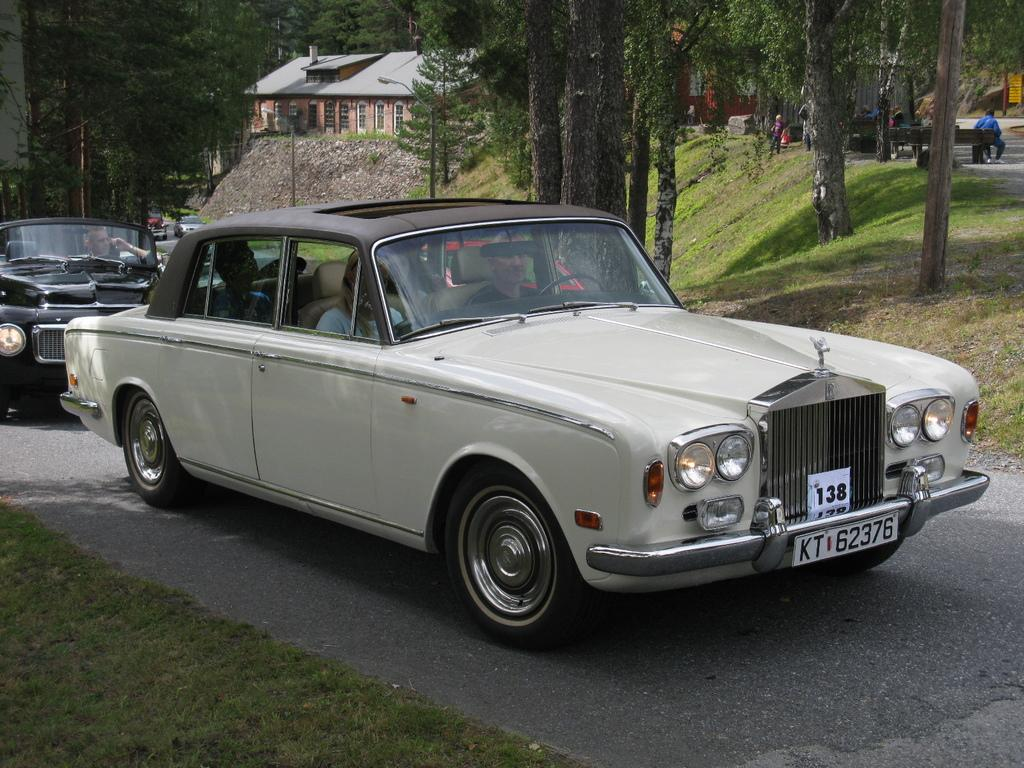What is in the center of the image? There are cars on the road in the center of the image. What can be seen at the bottom of the image? There is grass at the bottom of the image. What is visible in the background of the image? There are buildings, trees, and persons visible in the background. What type of pathway is present in the background? There is a road in the background. Can you see any fairies flying around the cars in the image? No, there are no fairies present in the image. What is the temper of the persons visible in the background? The provided facts do not give any information about the temper of the persons visible in the background. 